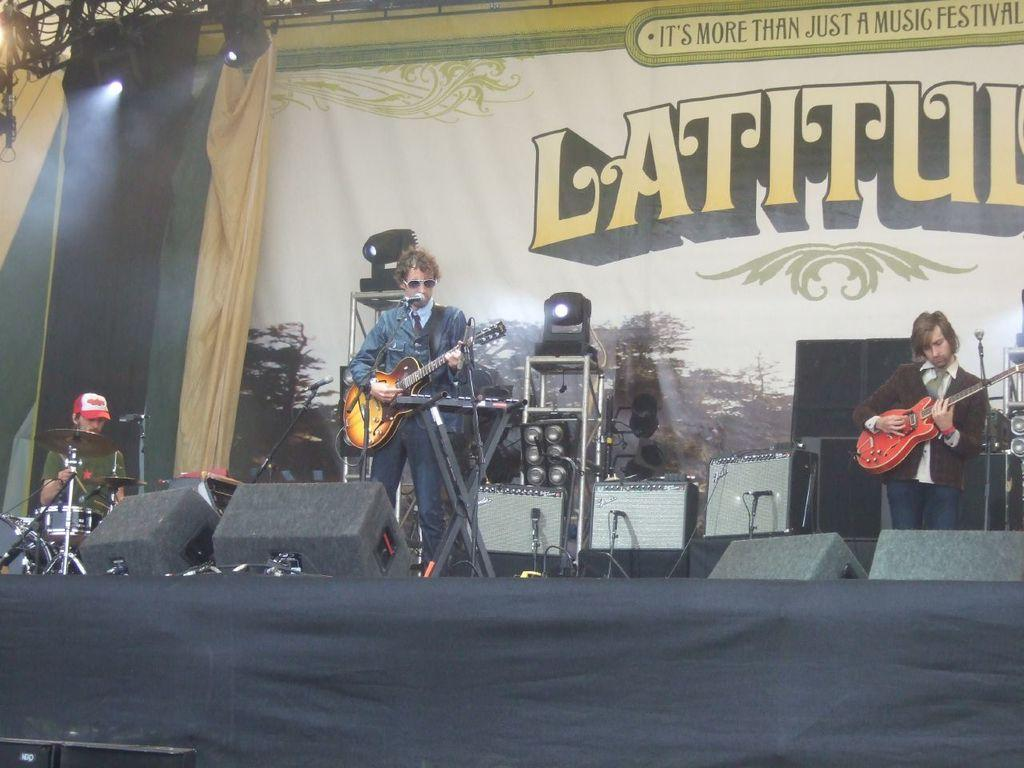What are the people in the image doing? The people in the image are standing and playing the guitar, while one person is sitting in front of a drum set. What instrument is the person sitting in front of playing? The person sitting in front of a drum set is playing the drums. How are the people who are standing interacting with the microphone? The people who are standing have a microphone in front of them, which suggests they may be singing or speaking into it. What type of owl can be seen perched on the governor's shoulder in the image? There is no owl or governor present in the image; it features people playing musical instruments. 